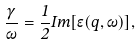<formula> <loc_0><loc_0><loc_500><loc_500>\frac { \gamma } { \omega } = \frac { 1 } { 2 } I m [ \epsilon ( q , \omega ) ] ,</formula> 